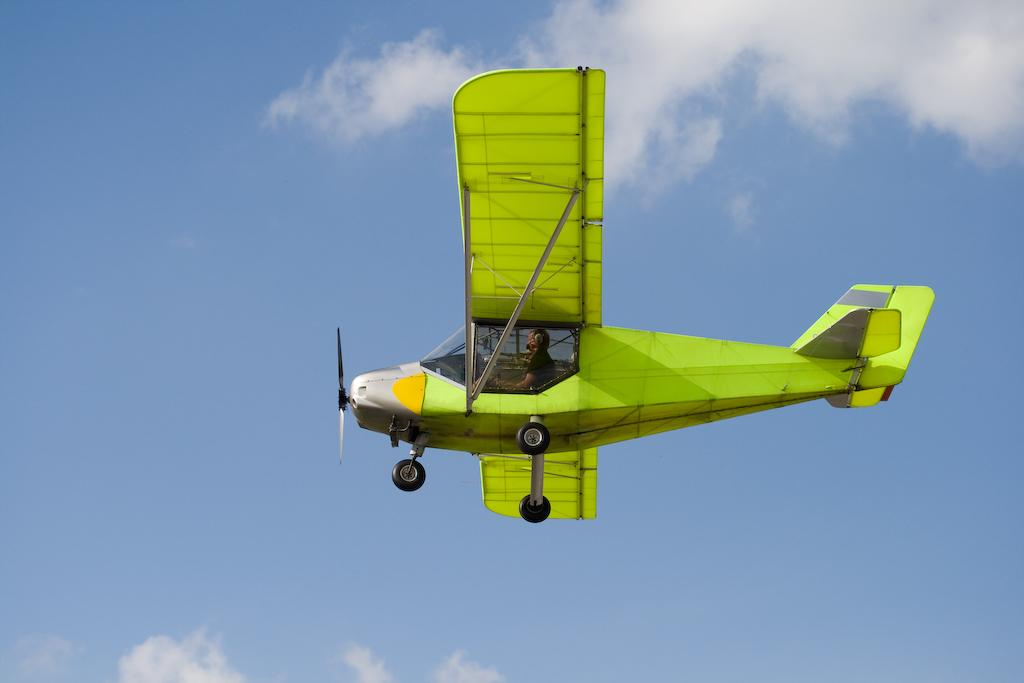What is the main subject of the image? The main subject of the image is an aircraft. Can you describe the position of the aircraft in the image? The aircraft is in the air in the image. Is there anyone inside the aircraft? Yes, there is a person sitting in the aircraft. What can be seen in the background of the image? The sky is visible in the background of the image. How would you describe the weather based on the image? The sky appears to be clear, suggesting good weather. What type of string is being used to hold the aircraft in the image? There is no string present in the image; the aircraft is flying in the air. What scent can be detected coming from the aircraft in the image? There is no mention of any scent in the image, as it focuses on the visual aspects of the aircraft and its surroundings. 